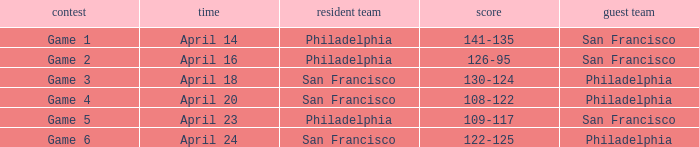On what date was game 2 played? April 16. 